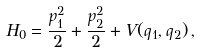Convert formula to latex. <formula><loc_0><loc_0><loc_500><loc_500>H _ { 0 } = \frac { p _ { 1 } ^ { 2 } } { 2 } + \frac { p _ { 2 } ^ { 2 } } { 2 } + V ( q _ { 1 } , q _ { 2 } ) \, ,</formula> 